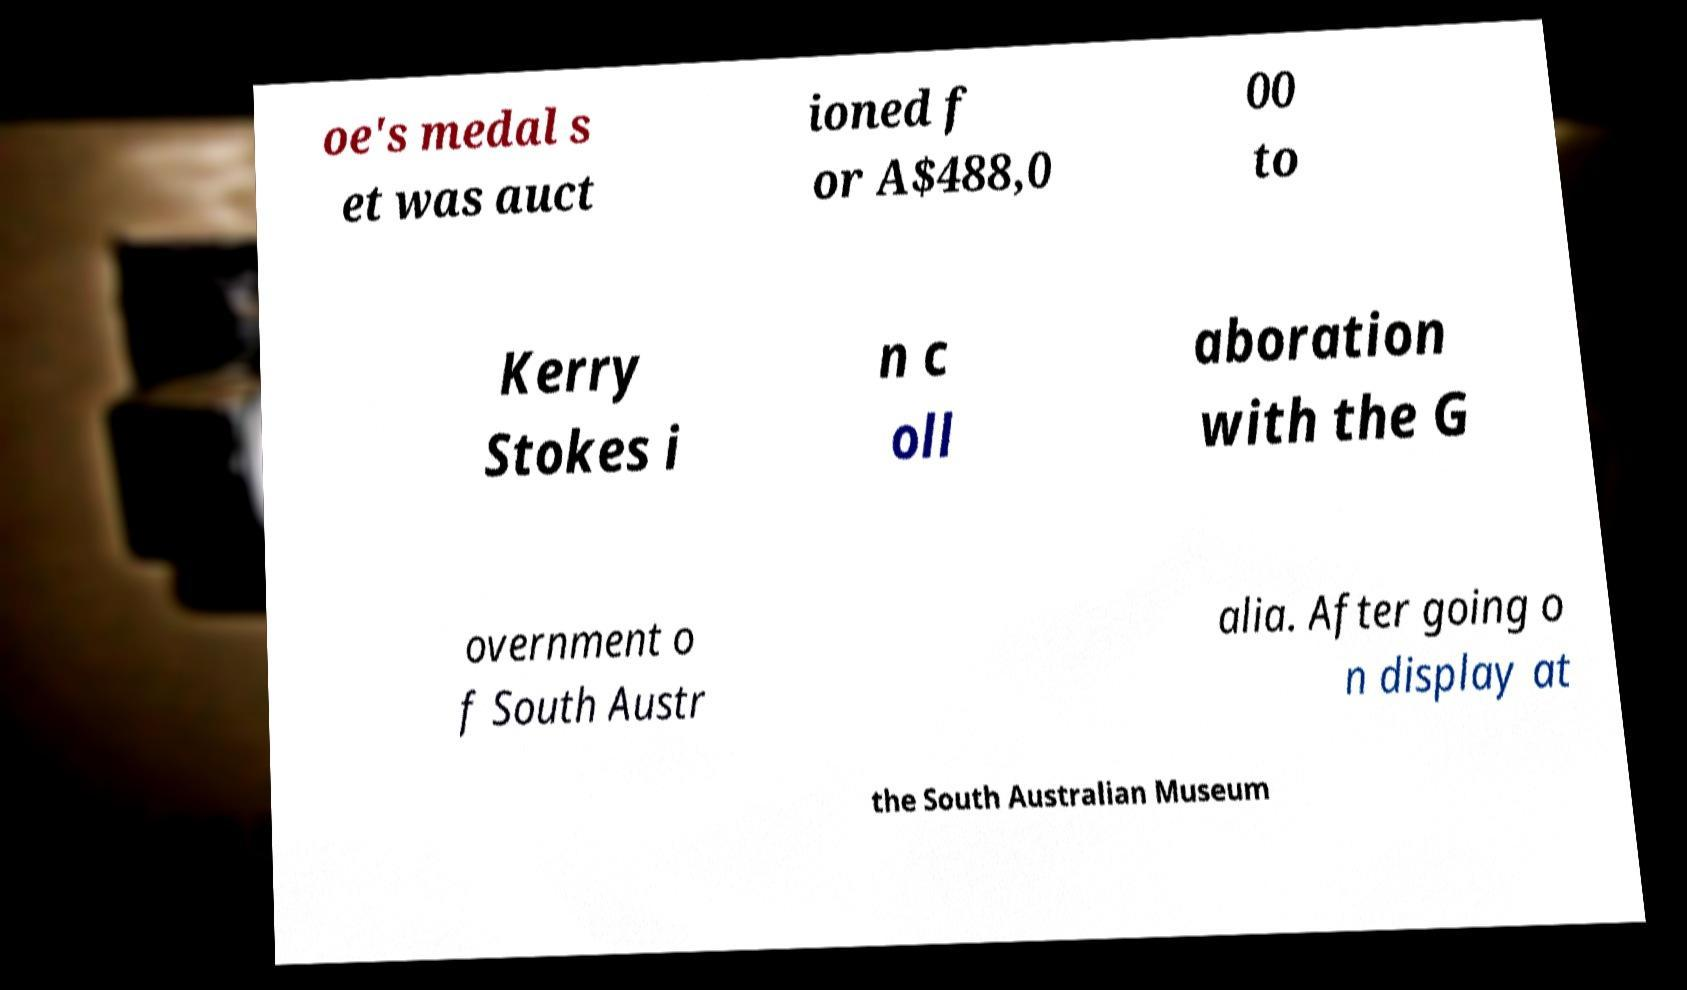What messages or text are displayed in this image? I need them in a readable, typed format. oe's medal s et was auct ioned f or A$488,0 00 to Kerry Stokes i n c oll aboration with the G overnment o f South Austr alia. After going o n display at the South Australian Museum 